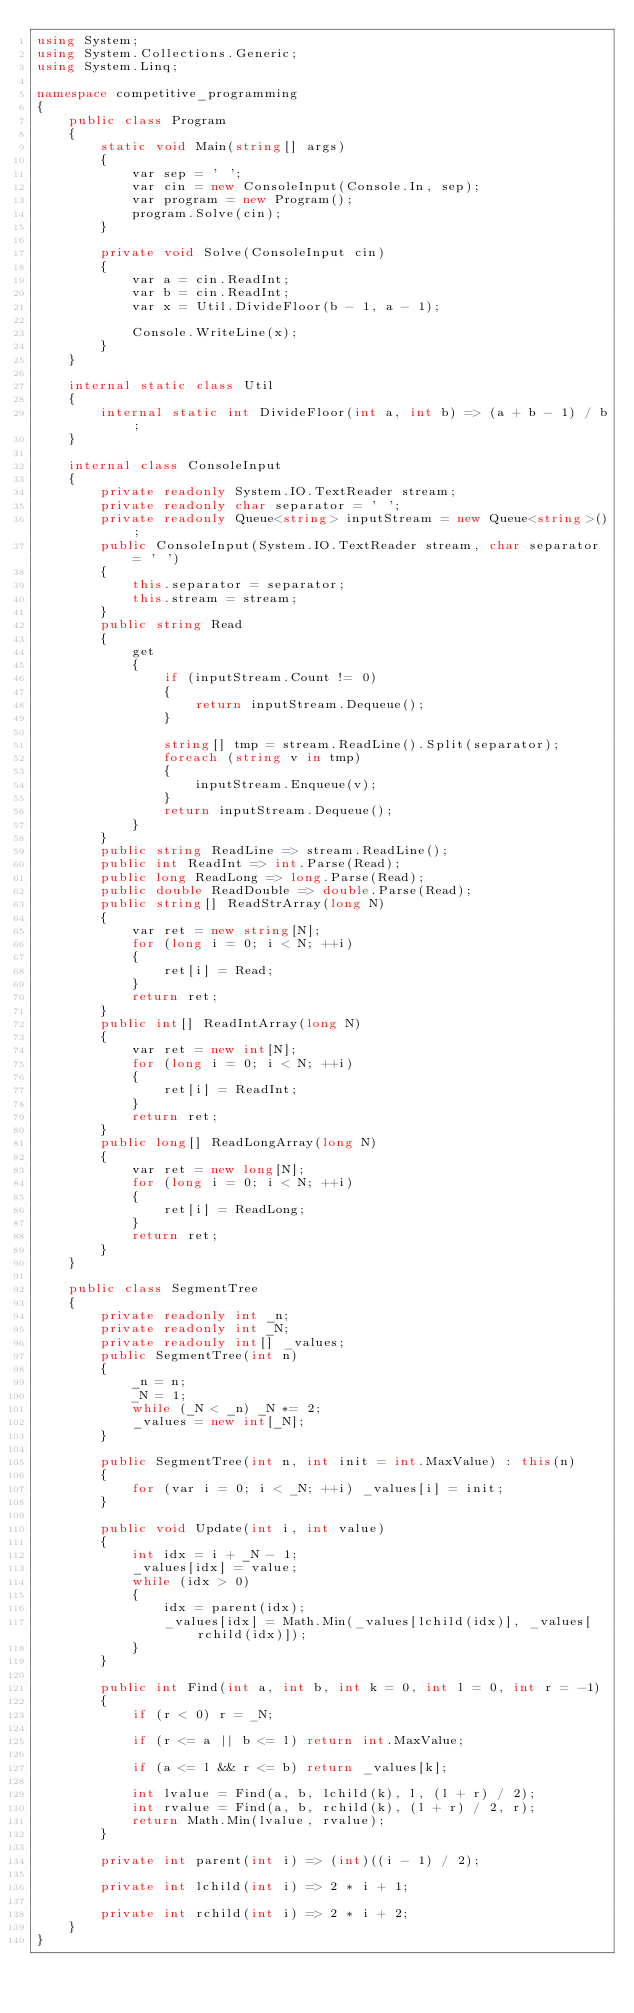<code> <loc_0><loc_0><loc_500><loc_500><_C#_>using System;
using System.Collections.Generic;
using System.Linq;

namespace competitive_programming
{
    public class Program
    {
        static void Main(string[] args)
        {
            var sep = ' ';
            var cin = new ConsoleInput(Console.In, sep);
            var program = new Program();
            program.Solve(cin);
        }

        private void Solve(ConsoleInput cin)
        {
            var a = cin.ReadInt;
            var b = cin.ReadInt;
            var x = Util.DivideFloor(b - 1, a - 1);

            Console.WriteLine(x);
        }
    }

    internal static class Util
    {
        internal static int DivideFloor(int a, int b) => (a + b - 1) / b;
    }

    internal class ConsoleInput
    {
        private readonly System.IO.TextReader stream;
        private readonly char separator = ' ';
        private readonly Queue<string> inputStream = new Queue<string>();
        public ConsoleInput(System.IO.TextReader stream, char separator = ' ')
        {
            this.separator = separator;
            this.stream = stream;
        }
        public string Read
        {
            get
            {
                if (inputStream.Count != 0)
                {
                    return inputStream.Dequeue();
                }

                string[] tmp = stream.ReadLine().Split(separator);
                foreach (string v in tmp)
                {
                    inputStream.Enqueue(v);
                }
                return inputStream.Dequeue();
            }
        }
        public string ReadLine => stream.ReadLine();
        public int ReadInt => int.Parse(Read);
        public long ReadLong => long.Parse(Read);
        public double ReadDouble => double.Parse(Read);
        public string[] ReadStrArray(long N)
        {
            var ret = new string[N];
            for (long i = 0; i < N; ++i)
            {
                ret[i] = Read;
            }
            return ret;
        }
        public int[] ReadIntArray(long N)
        {
            var ret = new int[N];
            for (long i = 0; i < N; ++i)
            {
                ret[i] = ReadInt;
            }
            return ret;
        }
        public long[] ReadLongArray(long N)
        {
            var ret = new long[N];
            for (long i = 0; i < N; ++i)
            {
                ret[i] = ReadLong;
            }
            return ret;
        }
    }

    public class SegmentTree
    {
        private readonly int _n;
        private readonly int _N;
        private readonly int[] _values;
        public SegmentTree(int n)
        {
            _n = n;
            _N = 1;
            while (_N < _n) _N *= 2;
            _values = new int[_N];
        }

        public SegmentTree(int n, int init = int.MaxValue) : this(n)
        {
            for (var i = 0; i < _N; ++i) _values[i] = init;
        }

        public void Update(int i, int value)
        {
            int idx = i + _N - 1;
            _values[idx] = value;
            while (idx > 0)
            {
                idx = parent(idx);
                _values[idx] = Math.Min(_values[lchild(idx)], _values[rchild(idx)]);
            }
        }

        public int Find(int a, int b, int k = 0, int l = 0, int r = -1)
        {
            if (r < 0) r = _N;

            if (r <= a || b <= l) return int.MaxValue;

            if (a <= l && r <= b) return _values[k];

            int lvalue = Find(a, b, lchild(k), l, (l + r) / 2);
            int rvalue = Find(a, b, rchild(k), (l + r) / 2, r);
            return Math.Min(lvalue, rvalue);
        }

        private int parent(int i) => (int)((i - 1) / 2);

        private int lchild(int i) => 2 * i + 1;

        private int rchild(int i) => 2 * i + 2;
    }
}
</code> 